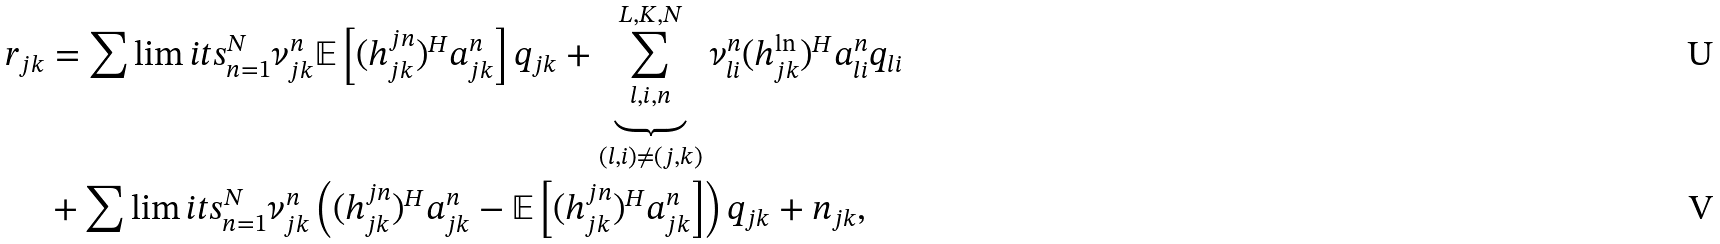Convert formula to latex. <formula><loc_0><loc_0><loc_500><loc_500>r _ { j k } & = \sum \lim i t s _ { n = 1 } ^ { N } \nu _ { j k } ^ { n } \mathbb { E } \left [ ( h _ { j k } ^ { j n } ) ^ { H } { a } _ { j k } ^ { n } \right ] q _ { j k } + \underbrace { \sum _ { l , i , n } ^ { L , K , N } } _ { ( l , i ) \neq ( j , k ) } \nu _ { l i } ^ { n } ( h _ { j k } ^ { \ln } ) ^ { H } { a } _ { l i } ^ { n } q _ { l i } \\ & + \sum \lim i t s _ { n = 1 } ^ { N } \nu _ { j k } ^ { n } \left ( ( h _ { j k } ^ { j n } ) ^ { H } { a } _ { j k } ^ { n } - \mathbb { E } \left [ ( h _ { j k } ^ { j n } ) ^ { H } { a } _ { j k } ^ { n } \right ] \right ) q _ { j k } + n _ { j k } ,</formula> 